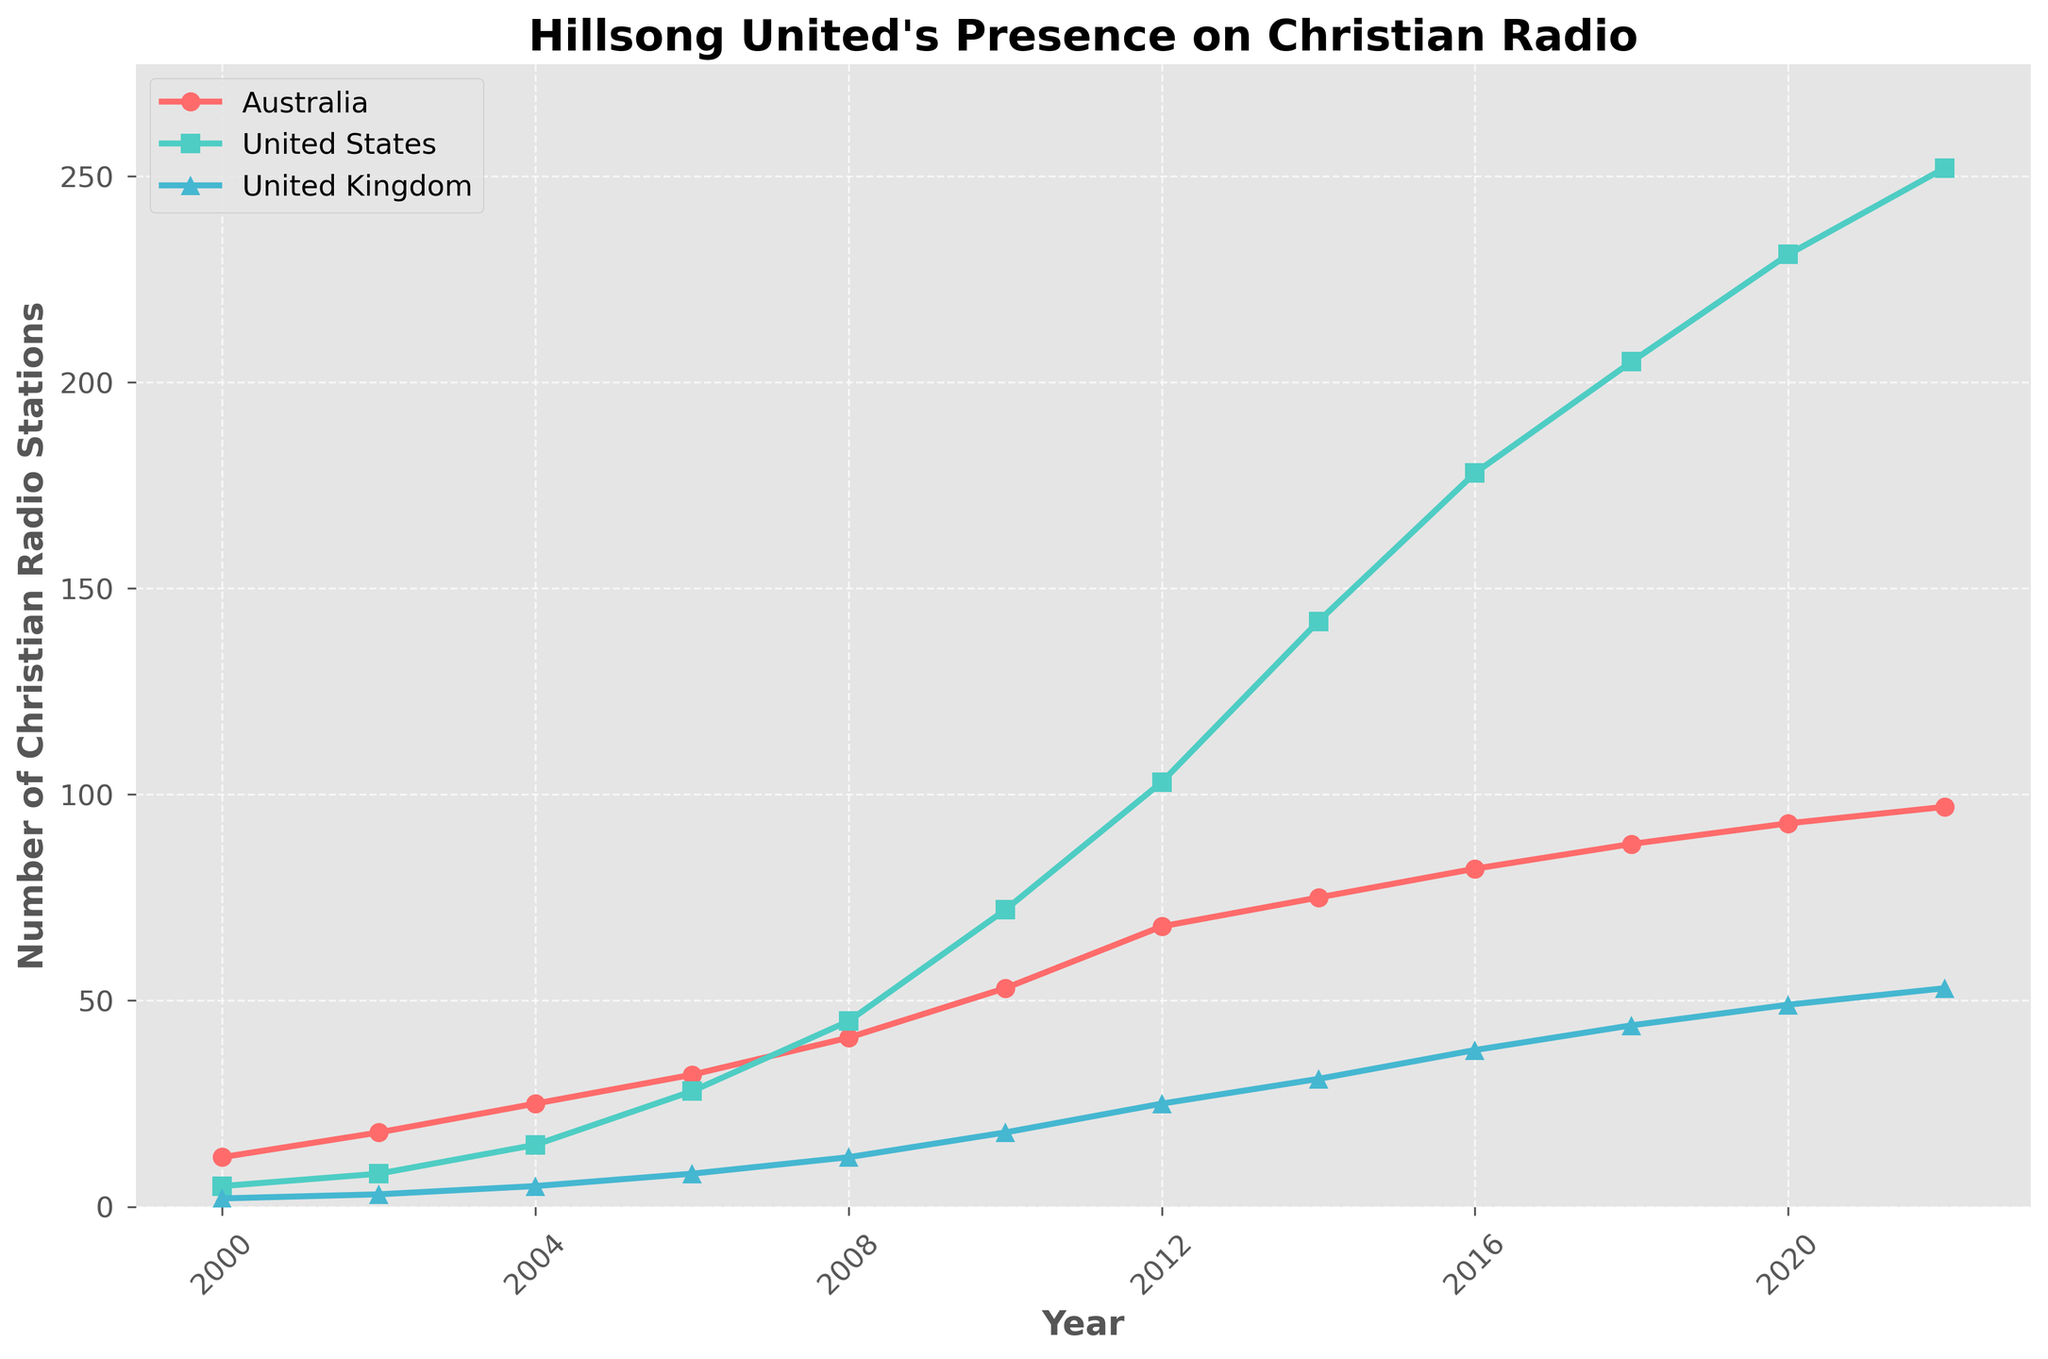How has the number of Christian radio stations in Australia changed from 2000 to 2022? To determine the change, subtract the number of stations in 2000 from the number of stations in 2022. This is 97 - 12 = 85.
Answer: 85 In which year did the United States surpass 100 Christian radio stations playing Hillsong United songs? By visually inspecting the graph, it is clear that the United States reaches and surpasses 100 stations in the year 2012.
Answer: 2012 Compare the growth rate of stations from 2000 to 2022 in the UK and Australia. Which one has a higher increase? The increase for the UK is 53 - 2 = 51, and for Australia, it's 97 - 12 = 85. Australia has a higher increase.
Answer: Australia What is the average number of radio stations in the United States over the years listed? Sum the number of stations for each year and divide by the number of years. (5 + 8 + 15 + 28 + 45 + 72 + 103 + 142 + 178 + 205 + 231 + 252) / 12 = 113.08
Answer: 113.08 Between 2010 and 2016, which country experienced the largest absolute increase in the number of stations? Calculate the differences for each country: Australia: 82 - 53 = 29; United States: 178 - 72 = 106; United Kingdom: 38 - 18 = 20. The United States experienced the largest increase.
Answer: United States How many more stations were there in the US compared to the UK in 2014? Subtract the number of UK stations from the US stations in 2014. This is 142 - 31 = 111.
Answer: 111 What is the approximate total number of radio stations in all three countries combined in 2022? Sum the number of stations in each country for 2022. 97 (Australia) + 252 (US) + 53 (UK) = 402.
Answer: 402 What trend in the number of stations is observed for all three countries between 2000 and 2008? Inspecting the graph, all three countries show a consistent increase in the number of radio stations over the years from 2000 to 2008.
Answer: Increase Which country had the smallest number of radio stations each year? By examining the graph for each year, the UK consistently had the smallest number of stations.
Answer: United Kingdom In what period did the number of stations in the UK change the most rapidly? To identify the period of most rapid change, look for the steepest increase in the graph. This is between 2010 and 2012.
Answer: 2010-2012 